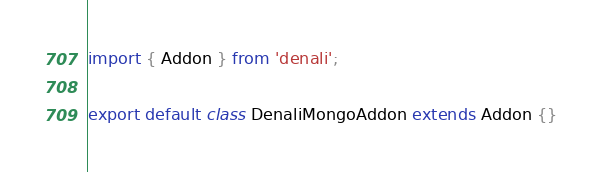<code> <loc_0><loc_0><loc_500><loc_500><_JavaScript_>import { Addon } from 'denali';

export default class DenaliMongoAddon extends Addon {}
</code> 